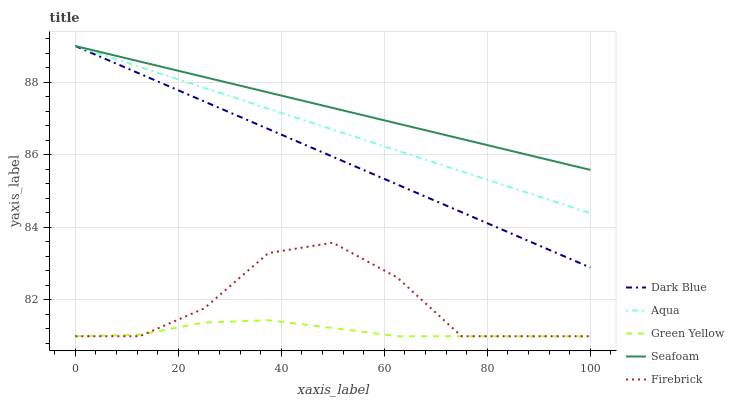Does Firebrick have the minimum area under the curve?
Answer yes or no. No. Does Firebrick have the maximum area under the curve?
Answer yes or no. No. Is Green Yellow the smoothest?
Answer yes or no. No. Is Green Yellow the roughest?
Answer yes or no. No. Does Aqua have the lowest value?
Answer yes or no. No. Does Firebrick have the highest value?
Answer yes or no. No. Is Green Yellow less than Seafoam?
Answer yes or no. Yes. Is Aqua greater than Green Yellow?
Answer yes or no. Yes. Does Green Yellow intersect Seafoam?
Answer yes or no. No. 